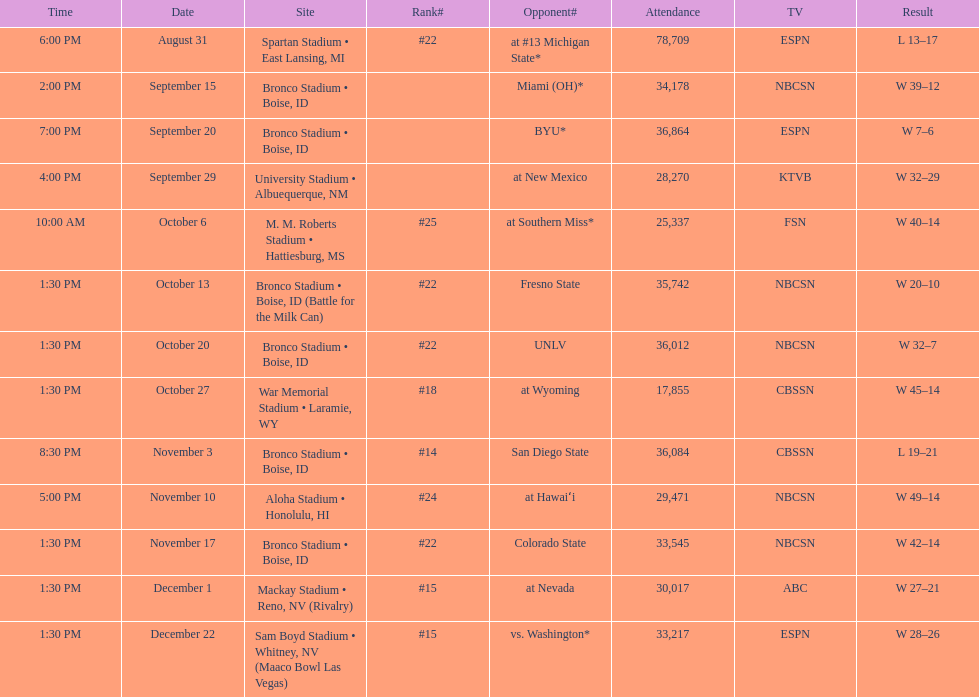Can you give me this table as a dict? {'header': ['Time', 'Date', 'Site', 'Rank#', 'Opponent#', 'Attendance', 'TV', 'Result'], 'rows': [['6:00 PM', 'August 31', 'Spartan Stadium • East Lansing, MI', '#22', 'at\xa0#13\xa0Michigan State*', '78,709', 'ESPN', 'L\xa013–17'], ['2:00 PM', 'September 15', 'Bronco Stadium • Boise, ID', '', 'Miami (OH)*', '34,178', 'NBCSN', 'W\xa039–12'], ['7:00 PM', 'September 20', 'Bronco Stadium • Boise, ID', '', 'BYU*', '36,864', 'ESPN', 'W\xa07–6'], ['4:00 PM', 'September 29', 'University Stadium • Albuequerque, NM', '', 'at\xa0New Mexico', '28,270', 'KTVB', 'W\xa032–29'], ['10:00 AM', 'October 6', 'M. M. Roberts Stadium • Hattiesburg, MS', '#25', 'at\xa0Southern Miss*', '25,337', 'FSN', 'W\xa040–14'], ['1:30 PM', 'October 13', 'Bronco Stadium • Boise, ID (Battle for the Milk Can)', '#22', 'Fresno State', '35,742', 'NBCSN', 'W\xa020–10'], ['1:30 PM', 'October 20', 'Bronco Stadium • Boise, ID', '#22', 'UNLV', '36,012', 'NBCSN', 'W\xa032–7'], ['1:30 PM', 'October 27', 'War Memorial Stadium • Laramie, WY', '#18', 'at\xa0Wyoming', '17,855', 'CBSSN', 'W\xa045–14'], ['8:30 PM', 'November 3', 'Bronco Stadium • Boise, ID', '#14', 'San Diego State', '36,084', 'CBSSN', 'L\xa019–21'], ['5:00 PM', 'November 10', 'Aloha Stadium • Honolulu, HI', '#24', 'at\xa0Hawaiʻi', '29,471', 'NBCSN', 'W\xa049–14'], ['1:30 PM', 'November 17', 'Bronco Stadium • Boise, ID', '#22', 'Colorado State', '33,545', 'NBCSN', 'W\xa042–14'], ['1:30 PM', 'December 1', 'Mackay Stadium • Reno, NV (Rivalry)', '#15', 'at\xa0Nevada', '30,017', 'ABC', 'W\xa027–21'], ['1:30 PM', 'December 22', 'Sam Boyd Stadium • Whitney, NV (Maaco Bowl Las Vegas)', '#15', 'vs.\xa0Washington*', '33,217', 'ESPN', 'W\xa028–26']]} Did the broncos on september 29th win by less than 5 points? Yes. 